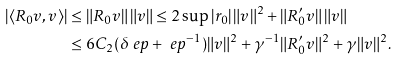Convert formula to latex. <formula><loc_0><loc_0><loc_500><loc_500>| \langle R _ { 0 } v , v \rangle | & \leq \| R _ { 0 } v \| \, \| v \| \leq 2 \sup | r _ { 0 } | \, \| v \| ^ { 2 } + \| R _ { 0 } ^ { \prime } v \| \, \| v \| \\ & \leq 6 C _ { 2 } ( \delta \ e p + \ e p ^ { - 1 } ) \| v \| ^ { 2 } + \gamma ^ { - 1 } \| R _ { 0 } ^ { \prime } v \| ^ { 2 } + \gamma \| v \| ^ { 2 } .</formula> 